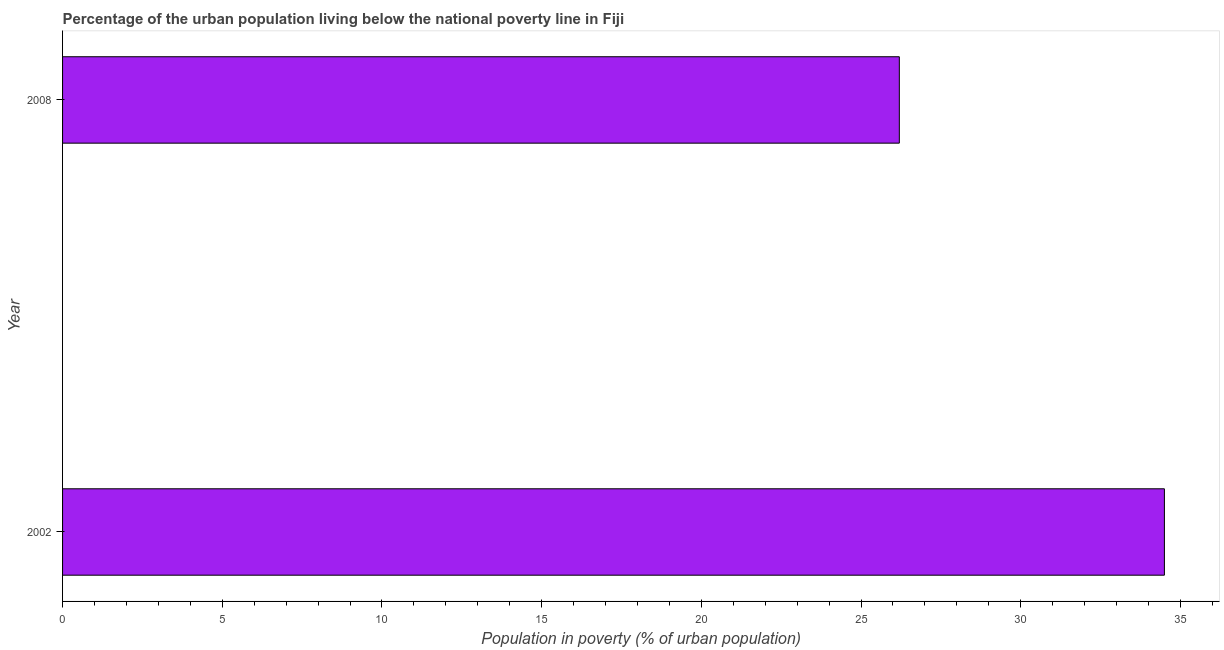Does the graph contain any zero values?
Give a very brief answer. No. Does the graph contain grids?
Offer a very short reply. No. What is the title of the graph?
Offer a terse response. Percentage of the urban population living below the national poverty line in Fiji. What is the label or title of the X-axis?
Keep it short and to the point. Population in poverty (% of urban population). What is the percentage of urban population living below poverty line in 2008?
Provide a succinct answer. 26.2. Across all years, what is the maximum percentage of urban population living below poverty line?
Give a very brief answer. 34.5. Across all years, what is the minimum percentage of urban population living below poverty line?
Keep it short and to the point. 26.2. What is the sum of the percentage of urban population living below poverty line?
Your answer should be compact. 60.7. What is the average percentage of urban population living below poverty line per year?
Offer a very short reply. 30.35. What is the median percentage of urban population living below poverty line?
Give a very brief answer. 30.35. In how many years, is the percentage of urban population living below poverty line greater than 19 %?
Provide a succinct answer. 2. Do a majority of the years between 2002 and 2008 (inclusive) have percentage of urban population living below poverty line greater than 11 %?
Keep it short and to the point. Yes. What is the ratio of the percentage of urban population living below poverty line in 2002 to that in 2008?
Ensure brevity in your answer.  1.32. Is the percentage of urban population living below poverty line in 2002 less than that in 2008?
Keep it short and to the point. No. In how many years, is the percentage of urban population living below poverty line greater than the average percentage of urban population living below poverty line taken over all years?
Provide a short and direct response. 1. How many bars are there?
Provide a succinct answer. 2. Are all the bars in the graph horizontal?
Your answer should be compact. Yes. How many years are there in the graph?
Offer a terse response. 2. What is the Population in poverty (% of urban population) in 2002?
Your response must be concise. 34.5. What is the Population in poverty (% of urban population) of 2008?
Offer a terse response. 26.2. What is the difference between the Population in poverty (% of urban population) in 2002 and 2008?
Give a very brief answer. 8.3. What is the ratio of the Population in poverty (% of urban population) in 2002 to that in 2008?
Provide a succinct answer. 1.32. 